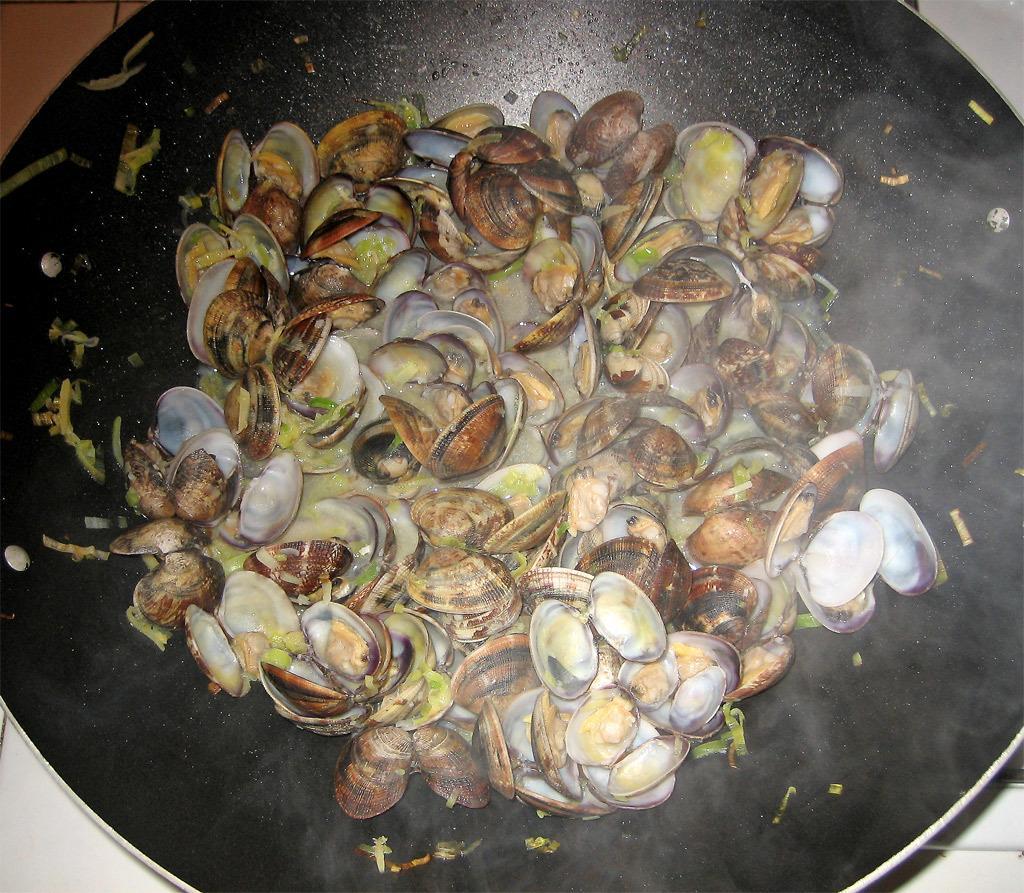Can you describe this image briefly? In this image, I can see a pan. This pan contains food item, which is made of mussels. 